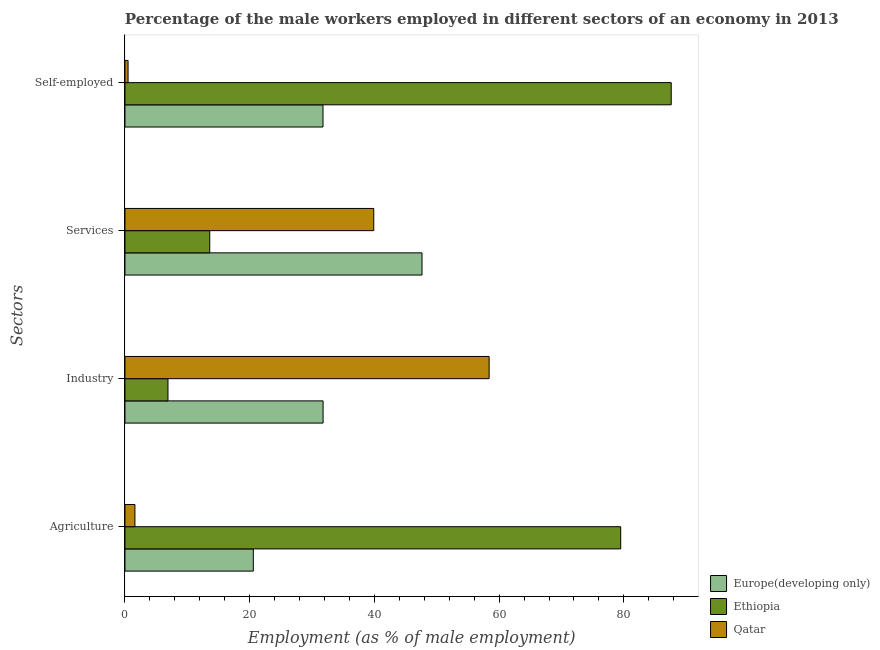How many different coloured bars are there?
Ensure brevity in your answer.  3. Are the number of bars per tick equal to the number of legend labels?
Offer a terse response. Yes. Are the number of bars on each tick of the Y-axis equal?
Provide a succinct answer. Yes. What is the label of the 4th group of bars from the top?
Keep it short and to the point. Agriculture. What is the percentage of self employed male workers in Europe(developing only)?
Give a very brief answer. 31.76. Across all countries, what is the maximum percentage of self employed male workers?
Your answer should be very brief. 87.6. Across all countries, what is the minimum percentage of male workers in industry?
Provide a succinct answer. 6.9. In which country was the percentage of male workers in agriculture maximum?
Provide a succinct answer. Ethiopia. In which country was the percentage of male workers in agriculture minimum?
Your response must be concise. Qatar. What is the total percentage of male workers in services in the graph?
Your response must be concise. 101.14. What is the difference between the percentage of self employed male workers in Europe(developing only) and that in Ethiopia?
Your answer should be very brief. -55.84. What is the difference between the percentage of male workers in industry in Europe(developing only) and the percentage of self employed male workers in Qatar?
Your answer should be compact. 31.27. What is the average percentage of self employed male workers per country?
Keep it short and to the point. 39.95. What is the difference between the percentage of male workers in agriculture and percentage of male workers in industry in Qatar?
Provide a succinct answer. -56.8. In how many countries, is the percentage of male workers in services greater than 40 %?
Give a very brief answer. 1. What is the ratio of the percentage of male workers in industry in Ethiopia to that in Europe(developing only)?
Your answer should be very brief. 0.22. Is the percentage of male workers in services in Europe(developing only) less than that in Qatar?
Your response must be concise. No. Is the difference between the percentage of male workers in industry in Qatar and Europe(developing only) greater than the difference between the percentage of male workers in services in Qatar and Europe(developing only)?
Provide a short and direct response. Yes. What is the difference between the highest and the second highest percentage of male workers in agriculture?
Your answer should be very brief. 58.91. What is the difference between the highest and the lowest percentage of male workers in services?
Provide a succinct answer. 34.04. In how many countries, is the percentage of male workers in services greater than the average percentage of male workers in services taken over all countries?
Give a very brief answer. 2. Is it the case that in every country, the sum of the percentage of male workers in services and percentage of self employed male workers is greater than the sum of percentage of male workers in agriculture and percentage of male workers in industry?
Provide a succinct answer. No. What does the 1st bar from the top in Agriculture represents?
Provide a succinct answer. Qatar. What does the 3rd bar from the bottom in Industry represents?
Your answer should be very brief. Qatar. Is it the case that in every country, the sum of the percentage of male workers in agriculture and percentage of male workers in industry is greater than the percentage of male workers in services?
Make the answer very short. Yes. How many bars are there?
Make the answer very short. 12. What is the difference between two consecutive major ticks on the X-axis?
Your response must be concise. 20. Does the graph contain any zero values?
Your answer should be compact. No. Does the graph contain grids?
Keep it short and to the point. No. Where does the legend appear in the graph?
Offer a terse response. Bottom right. What is the title of the graph?
Give a very brief answer. Percentage of the male workers employed in different sectors of an economy in 2013. What is the label or title of the X-axis?
Make the answer very short. Employment (as % of male employment). What is the label or title of the Y-axis?
Keep it short and to the point. Sectors. What is the Employment (as % of male employment) of Europe(developing only) in Agriculture?
Provide a short and direct response. 20.59. What is the Employment (as % of male employment) in Ethiopia in Agriculture?
Keep it short and to the point. 79.5. What is the Employment (as % of male employment) in Qatar in Agriculture?
Give a very brief answer. 1.6. What is the Employment (as % of male employment) of Europe(developing only) in Industry?
Provide a succinct answer. 31.77. What is the Employment (as % of male employment) of Ethiopia in Industry?
Make the answer very short. 6.9. What is the Employment (as % of male employment) of Qatar in Industry?
Keep it short and to the point. 58.4. What is the Employment (as % of male employment) of Europe(developing only) in Services?
Your answer should be very brief. 47.64. What is the Employment (as % of male employment) in Ethiopia in Services?
Make the answer very short. 13.6. What is the Employment (as % of male employment) in Qatar in Services?
Keep it short and to the point. 39.9. What is the Employment (as % of male employment) in Europe(developing only) in Self-employed?
Offer a terse response. 31.76. What is the Employment (as % of male employment) of Ethiopia in Self-employed?
Give a very brief answer. 87.6. What is the Employment (as % of male employment) of Qatar in Self-employed?
Provide a succinct answer. 0.5. Across all Sectors, what is the maximum Employment (as % of male employment) in Europe(developing only)?
Ensure brevity in your answer.  47.64. Across all Sectors, what is the maximum Employment (as % of male employment) of Ethiopia?
Your response must be concise. 87.6. Across all Sectors, what is the maximum Employment (as % of male employment) in Qatar?
Provide a short and direct response. 58.4. Across all Sectors, what is the minimum Employment (as % of male employment) in Europe(developing only)?
Make the answer very short. 20.59. Across all Sectors, what is the minimum Employment (as % of male employment) in Ethiopia?
Provide a succinct answer. 6.9. What is the total Employment (as % of male employment) in Europe(developing only) in the graph?
Your answer should be very brief. 131.75. What is the total Employment (as % of male employment) of Ethiopia in the graph?
Offer a very short reply. 187.6. What is the total Employment (as % of male employment) in Qatar in the graph?
Keep it short and to the point. 100.4. What is the difference between the Employment (as % of male employment) of Europe(developing only) in Agriculture and that in Industry?
Provide a succinct answer. -11.19. What is the difference between the Employment (as % of male employment) of Ethiopia in Agriculture and that in Industry?
Keep it short and to the point. 72.6. What is the difference between the Employment (as % of male employment) of Qatar in Agriculture and that in Industry?
Offer a very short reply. -56.8. What is the difference between the Employment (as % of male employment) in Europe(developing only) in Agriculture and that in Services?
Keep it short and to the point. -27.05. What is the difference between the Employment (as % of male employment) in Ethiopia in Agriculture and that in Services?
Make the answer very short. 65.9. What is the difference between the Employment (as % of male employment) of Qatar in Agriculture and that in Services?
Your answer should be compact. -38.3. What is the difference between the Employment (as % of male employment) in Europe(developing only) in Agriculture and that in Self-employed?
Provide a short and direct response. -11.17. What is the difference between the Employment (as % of male employment) of Europe(developing only) in Industry and that in Services?
Your answer should be compact. -15.86. What is the difference between the Employment (as % of male employment) of Qatar in Industry and that in Services?
Provide a short and direct response. 18.5. What is the difference between the Employment (as % of male employment) of Europe(developing only) in Industry and that in Self-employed?
Give a very brief answer. 0.01. What is the difference between the Employment (as % of male employment) of Ethiopia in Industry and that in Self-employed?
Provide a succinct answer. -80.7. What is the difference between the Employment (as % of male employment) of Qatar in Industry and that in Self-employed?
Your answer should be very brief. 57.9. What is the difference between the Employment (as % of male employment) in Europe(developing only) in Services and that in Self-employed?
Your answer should be very brief. 15.88. What is the difference between the Employment (as % of male employment) of Ethiopia in Services and that in Self-employed?
Give a very brief answer. -74. What is the difference between the Employment (as % of male employment) in Qatar in Services and that in Self-employed?
Ensure brevity in your answer.  39.4. What is the difference between the Employment (as % of male employment) in Europe(developing only) in Agriculture and the Employment (as % of male employment) in Ethiopia in Industry?
Keep it short and to the point. 13.69. What is the difference between the Employment (as % of male employment) of Europe(developing only) in Agriculture and the Employment (as % of male employment) of Qatar in Industry?
Make the answer very short. -37.81. What is the difference between the Employment (as % of male employment) in Ethiopia in Agriculture and the Employment (as % of male employment) in Qatar in Industry?
Make the answer very short. 21.1. What is the difference between the Employment (as % of male employment) of Europe(developing only) in Agriculture and the Employment (as % of male employment) of Ethiopia in Services?
Offer a very short reply. 6.99. What is the difference between the Employment (as % of male employment) of Europe(developing only) in Agriculture and the Employment (as % of male employment) of Qatar in Services?
Your answer should be compact. -19.31. What is the difference between the Employment (as % of male employment) of Ethiopia in Agriculture and the Employment (as % of male employment) of Qatar in Services?
Keep it short and to the point. 39.6. What is the difference between the Employment (as % of male employment) in Europe(developing only) in Agriculture and the Employment (as % of male employment) in Ethiopia in Self-employed?
Give a very brief answer. -67.01. What is the difference between the Employment (as % of male employment) of Europe(developing only) in Agriculture and the Employment (as % of male employment) of Qatar in Self-employed?
Provide a succinct answer. 20.09. What is the difference between the Employment (as % of male employment) in Ethiopia in Agriculture and the Employment (as % of male employment) in Qatar in Self-employed?
Offer a very short reply. 79. What is the difference between the Employment (as % of male employment) in Europe(developing only) in Industry and the Employment (as % of male employment) in Ethiopia in Services?
Ensure brevity in your answer.  18.17. What is the difference between the Employment (as % of male employment) of Europe(developing only) in Industry and the Employment (as % of male employment) of Qatar in Services?
Offer a terse response. -8.13. What is the difference between the Employment (as % of male employment) of Ethiopia in Industry and the Employment (as % of male employment) of Qatar in Services?
Offer a very short reply. -33. What is the difference between the Employment (as % of male employment) in Europe(developing only) in Industry and the Employment (as % of male employment) in Ethiopia in Self-employed?
Make the answer very short. -55.83. What is the difference between the Employment (as % of male employment) of Europe(developing only) in Industry and the Employment (as % of male employment) of Qatar in Self-employed?
Make the answer very short. 31.27. What is the difference between the Employment (as % of male employment) of Europe(developing only) in Services and the Employment (as % of male employment) of Ethiopia in Self-employed?
Give a very brief answer. -39.96. What is the difference between the Employment (as % of male employment) in Europe(developing only) in Services and the Employment (as % of male employment) in Qatar in Self-employed?
Keep it short and to the point. 47.14. What is the difference between the Employment (as % of male employment) of Ethiopia in Services and the Employment (as % of male employment) of Qatar in Self-employed?
Give a very brief answer. 13.1. What is the average Employment (as % of male employment) of Europe(developing only) per Sectors?
Provide a short and direct response. 32.94. What is the average Employment (as % of male employment) of Ethiopia per Sectors?
Your answer should be compact. 46.9. What is the average Employment (as % of male employment) of Qatar per Sectors?
Provide a short and direct response. 25.1. What is the difference between the Employment (as % of male employment) in Europe(developing only) and Employment (as % of male employment) in Ethiopia in Agriculture?
Make the answer very short. -58.91. What is the difference between the Employment (as % of male employment) in Europe(developing only) and Employment (as % of male employment) in Qatar in Agriculture?
Keep it short and to the point. 18.99. What is the difference between the Employment (as % of male employment) of Ethiopia and Employment (as % of male employment) of Qatar in Agriculture?
Your answer should be very brief. 77.9. What is the difference between the Employment (as % of male employment) of Europe(developing only) and Employment (as % of male employment) of Ethiopia in Industry?
Keep it short and to the point. 24.87. What is the difference between the Employment (as % of male employment) of Europe(developing only) and Employment (as % of male employment) of Qatar in Industry?
Keep it short and to the point. -26.63. What is the difference between the Employment (as % of male employment) of Ethiopia and Employment (as % of male employment) of Qatar in Industry?
Ensure brevity in your answer.  -51.5. What is the difference between the Employment (as % of male employment) of Europe(developing only) and Employment (as % of male employment) of Ethiopia in Services?
Offer a terse response. 34.04. What is the difference between the Employment (as % of male employment) of Europe(developing only) and Employment (as % of male employment) of Qatar in Services?
Provide a succinct answer. 7.74. What is the difference between the Employment (as % of male employment) of Ethiopia and Employment (as % of male employment) of Qatar in Services?
Your answer should be very brief. -26.3. What is the difference between the Employment (as % of male employment) of Europe(developing only) and Employment (as % of male employment) of Ethiopia in Self-employed?
Your answer should be compact. -55.84. What is the difference between the Employment (as % of male employment) in Europe(developing only) and Employment (as % of male employment) in Qatar in Self-employed?
Your answer should be very brief. 31.26. What is the difference between the Employment (as % of male employment) of Ethiopia and Employment (as % of male employment) of Qatar in Self-employed?
Provide a succinct answer. 87.1. What is the ratio of the Employment (as % of male employment) in Europe(developing only) in Agriculture to that in Industry?
Provide a short and direct response. 0.65. What is the ratio of the Employment (as % of male employment) in Ethiopia in Agriculture to that in Industry?
Offer a very short reply. 11.52. What is the ratio of the Employment (as % of male employment) in Qatar in Agriculture to that in Industry?
Your answer should be very brief. 0.03. What is the ratio of the Employment (as % of male employment) in Europe(developing only) in Agriculture to that in Services?
Your answer should be very brief. 0.43. What is the ratio of the Employment (as % of male employment) of Ethiopia in Agriculture to that in Services?
Provide a short and direct response. 5.85. What is the ratio of the Employment (as % of male employment) of Qatar in Agriculture to that in Services?
Your response must be concise. 0.04. What is the ratio of the Employment (as % of male employment) in Europe(developing only) in Agriculture to that in Self-employed?
Offer a very short reply. 0.65. What is the ratio of the Employment (as % of male employment) in Ethiopia in Agriculture to that in Self-employed?
Offer a very short reply. 0.91. What is the ratio of the Employment (as % of male employment) in Qatar in Agriculture to that in Self-employed?
Provide a succinct answer. 3.2. What is the ratio of the Employment (as % of male employment) of Europe(developing only) in Industry to that in Services?
Your answer should be very brief. 0.67. What is the ratio of the Employment (as % of male employment) in Ethiopia in Industry to that in Services?
Offer a very short reply. 0.51. What is the ratio of the Employment (as % of male employment) in Qatar in Industry to that in Services?
Offer a very short reply. 1.46. What is the ratio of the Employment (as % of male employment) of Ethiopia in Industry to that in Self-employed?
Ensure brevity in your answer.  0.08. What is the ratio of the Employment (as % of male employment) in Qatar in Industry to that in Self-employed?
Your answer should be very brief. 116.8. What is the ratio of the Employment (as % of male employment) of Europe(developing only) in Services to that in Self-employed?
Keep it short and to the point. 1.5. What is the ratio of the Employment (as % of male employment) of Ethiopia in Services to that in Self-employed?
Make the answer very short. 0.16. What is the ratio of the Employment (as % of male employment) of Qatar in Services to that in Self-employed?
Make the answer very short. 79.8. What is the difference between the highest and the second highest Employment (as % of male employment) of Europe(developing only)?
Your answer should be compact. 15.86. What is the difference between the highest and the lowest Employment (as % of male employment) in Europe(developing only)?
Make the answer very short. 27.05. What is the difference between the highest and the lowest Employment (as % of male employment) in Ethiopia?
Offer a terse response. 80.7. What is the difference between the highest and the lowest Employment (as % of male employment) of Qatar?
Give a very brief answer. 57.9. 